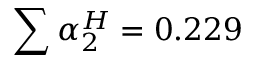Convert formula to latex. <formula><loc_0><loc_0><loc_500><loc_500>\sum \alpha _ { 2 } ^ { H } = 0 . 2 2 9</formula> 